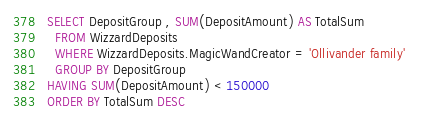<code> <loc_0><loc_0><loc_500><loc_500><_SQL_>SELECT DepositGroup , SUM(DepositAmount) AS TotalSum
  FROM WizzardDeposits
  WHERE WizzardDeposits.MagicWandCreator = 'Ollivander family' 
  GROUP BY DepositGroup    
HAVING SUM(DepositAmount) < 150000                     
ORDER BY TotalSum DESC
</code> 